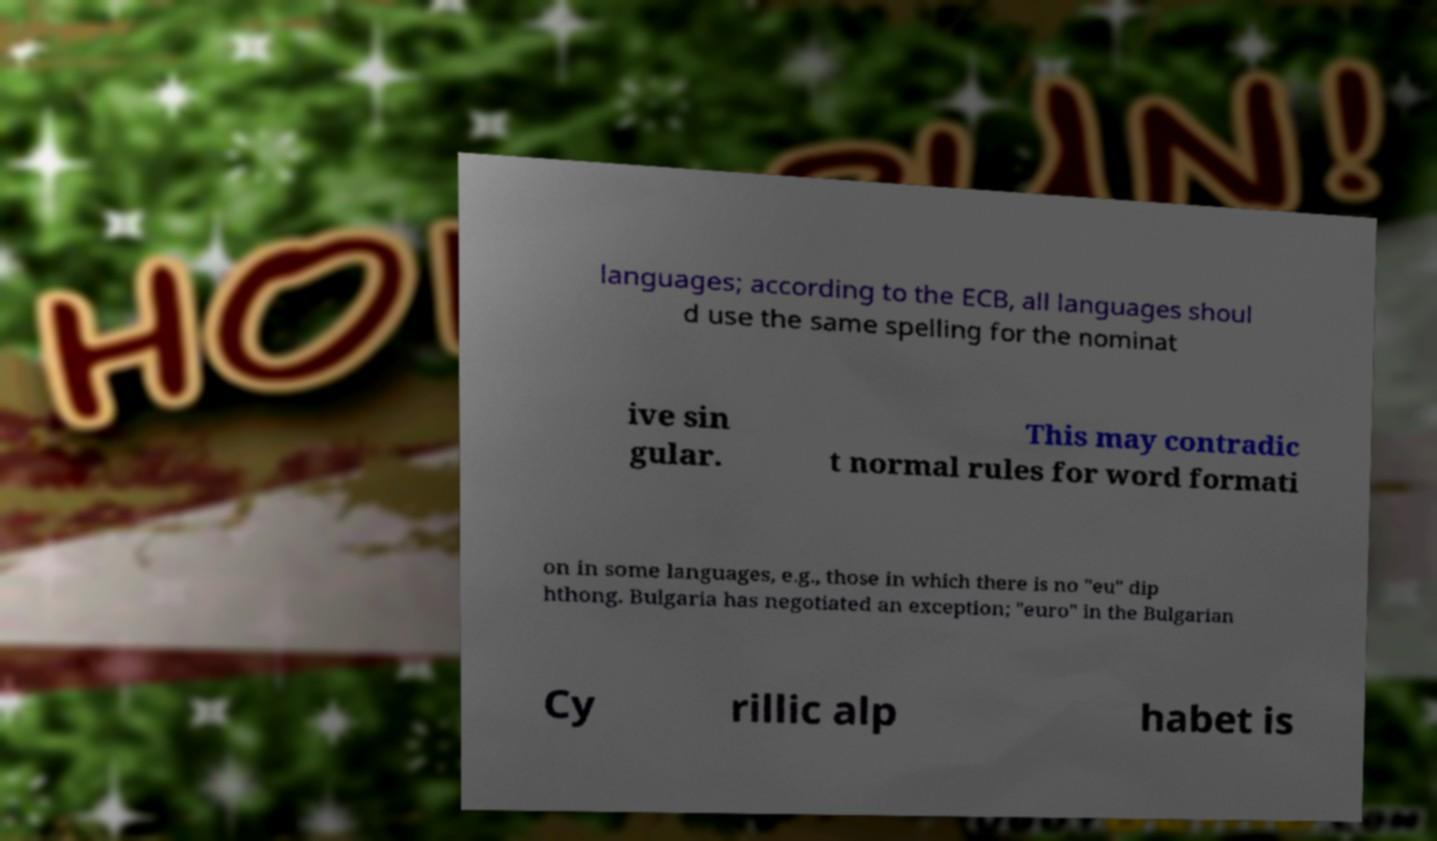Please read and relay the text visible in this image. What does it say? languages; according to the ECB, all languages shoul d use the same spelling for the nominat ive sin gular. This may contradic t normal rules for word formati on in some languages, e.g., those in which there is no "eu" dip hthong. Bulgaria has negotiated an exception; "euro" in the Bulgarian Cy rillic alp habet is 